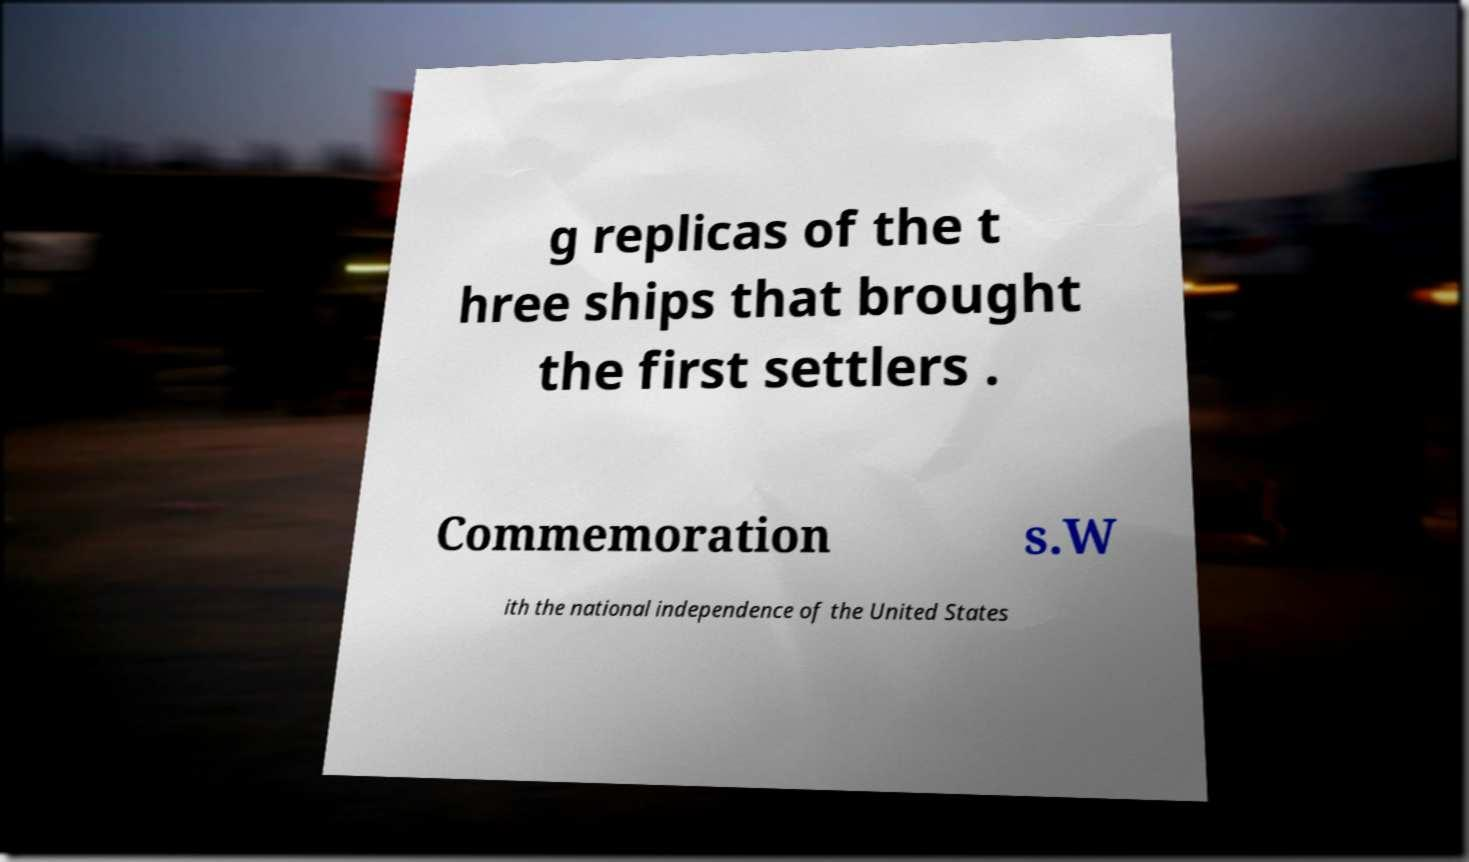What messages or text are displayed in this image? I need them in a readable, typed format. g replicas of the t hree ships that brought the first settlers . Commemoration s.W ith the national independence of the United States 